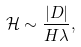Convert formula to latex. <formula><loc_0><loc_0><loc_500><loc_500>\mathcal { H } \sim \frac { | D | } { H \lambda } ,</formula> 